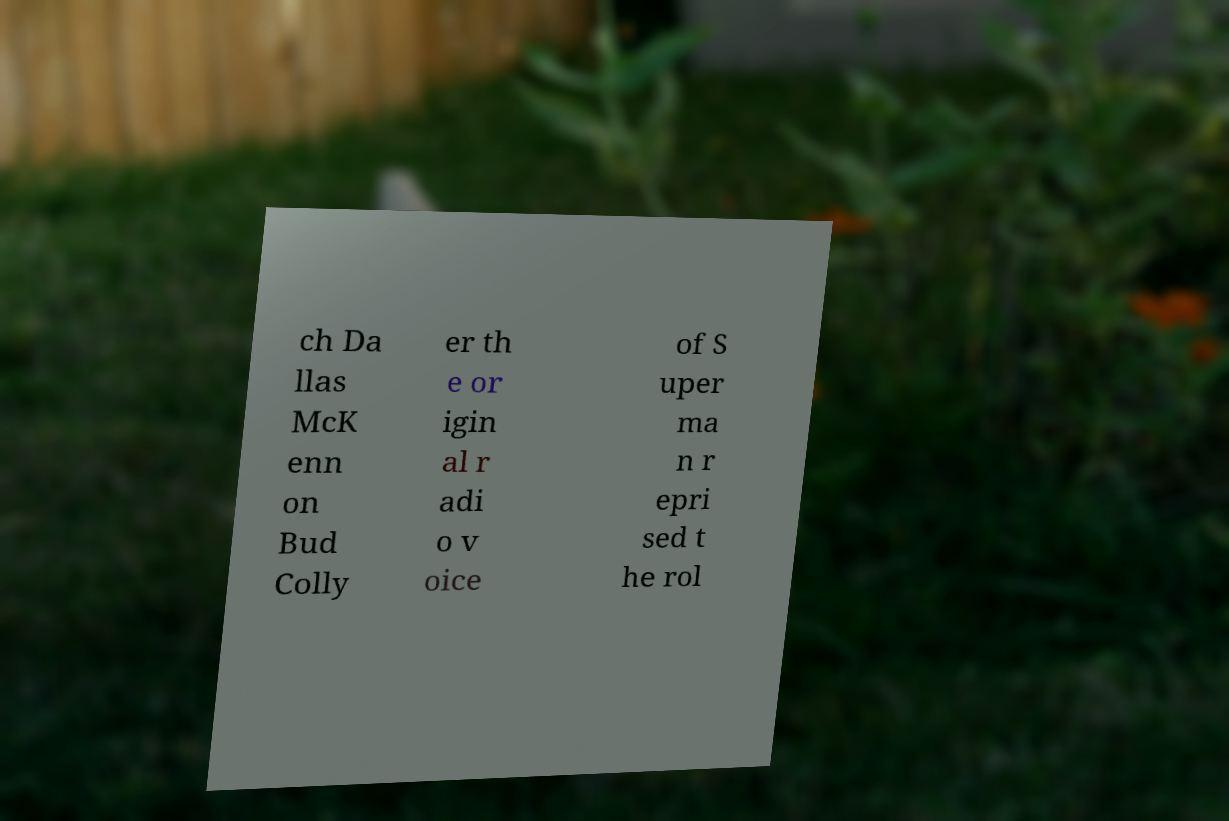Could you assist in decoding the text presented in this image and type it out clearly? ch Da llas McK enn on Bud Colly er th e or igin al r adi o v oice of S uper ma n r epri sed t he rol 